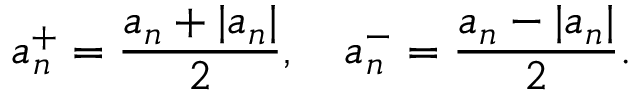Convert formula to latex. <formula><loc_0><loc_0><loc_500><loc_500>a _ { n } ^ { + } = { \frac { a _ { n } + | a _ { n } | } { 2 } } , \quad a _ { n } ^ { - } = { \frac { a _ { n } - | a _ { n } | } { 2 } } .</formula> 